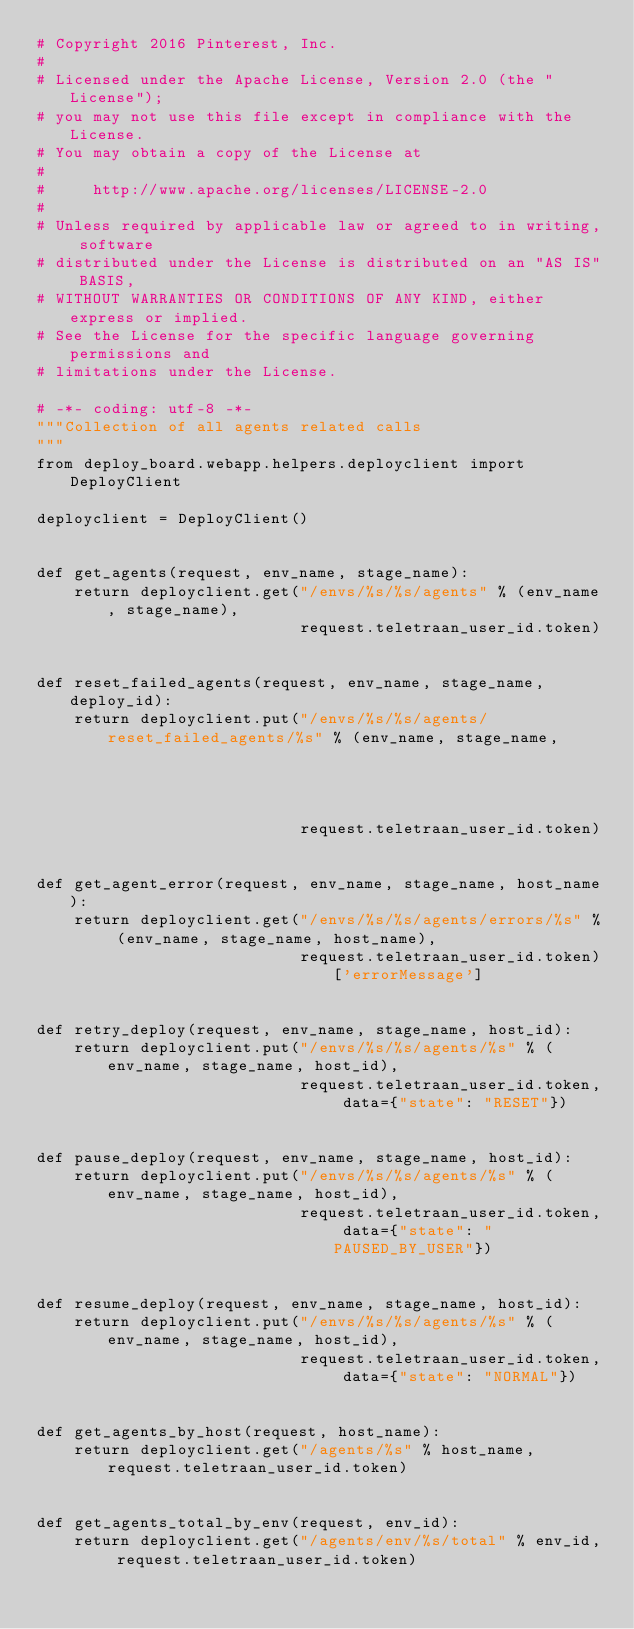Convert code to text. <code><loc_0><loc_0><loc_500><loc_500><_Python_># Copyright 2016 Pinterest, Inc.
#
# Licensed under the Apache License, Version 2.0 (the "License");
# you may not use this file except in compliance with the License.
# You may obtain a copy of the License at
#  
#     http://www.apache.org/licenses/LICENSE-2.0
#    
# Unless required by applicable law or agreed to in writing, software
# distributed under the License is distributed on an "AS IS" BASIS,
# WITHOUT WARRANTIES OR CONDITIONS OF ANY KIND, either express or implied.
# See the License for the specific language governing permissions and
# limitations under the License.

# -*- coding: utf-8 -*-
"""Collection of all agents related calls
"""
from deploy_board.webapp.helpers.deployclient import DeployClient

deployclient = DeployClient()


def get_agents(request, env_name, stage_name):
    return deployclient.get("/envs/%s/%s/agents" % (env_name, stage_name),
                            request.teletraan_user_id.token)


def reset_failed_agents(request, env_name, stage_name, deploy_id):
    return deployclient.put("/envs/%s/%s/agents/reset_failed_agents/%s" % (env_name, stage_name,
                                                                           deploy_id),
                            request.teletraan_user_id.token)


def get_agent_error(request, env_name, stage_name, host_name):
    return deployclient.get("/envs/%s/%s/agents/errors/%s" % (env_name, stage_name, host_name),
                            request.teletraan_user_id.token)['errorMessage']


def retry_deploy(request, env_name, stage_name, host_id):
    return deployclient.put("/envs/%s/%s/agents/%s" % (env_name, stage_name, host_id),
                            request.teletraan_user_id.token, data={"state": "RESET"})


def pause_deploy(request, env_name, stage_name, host_id):
    return deployclient.put("/envs/%s/%s/agents/%s" % (env_name, stage_name, host_id),
                            request.teletraan_user_id.token, data={"state": "PAUSED_BY_USER"})


def resume_deploy(request, env_name, stage_name, host_id):
    return deployclient.put("/envs/%s/%s/agents/%s" % (env_name, stage_name, host_id),
                            request.teletraan_user_id.token, data={"state": "NORMAL"})


def get_agents_by_host(request, host_name):
    return deployclient.get("/agents/%s" % host_name, request.teletraan_user_id.token)
    

def get_agents_total_by_env(request, env_id):
    return deployclient.get("/agents/env/%s/total" % env_id, request.teletraan_user_id.token)
</code> 